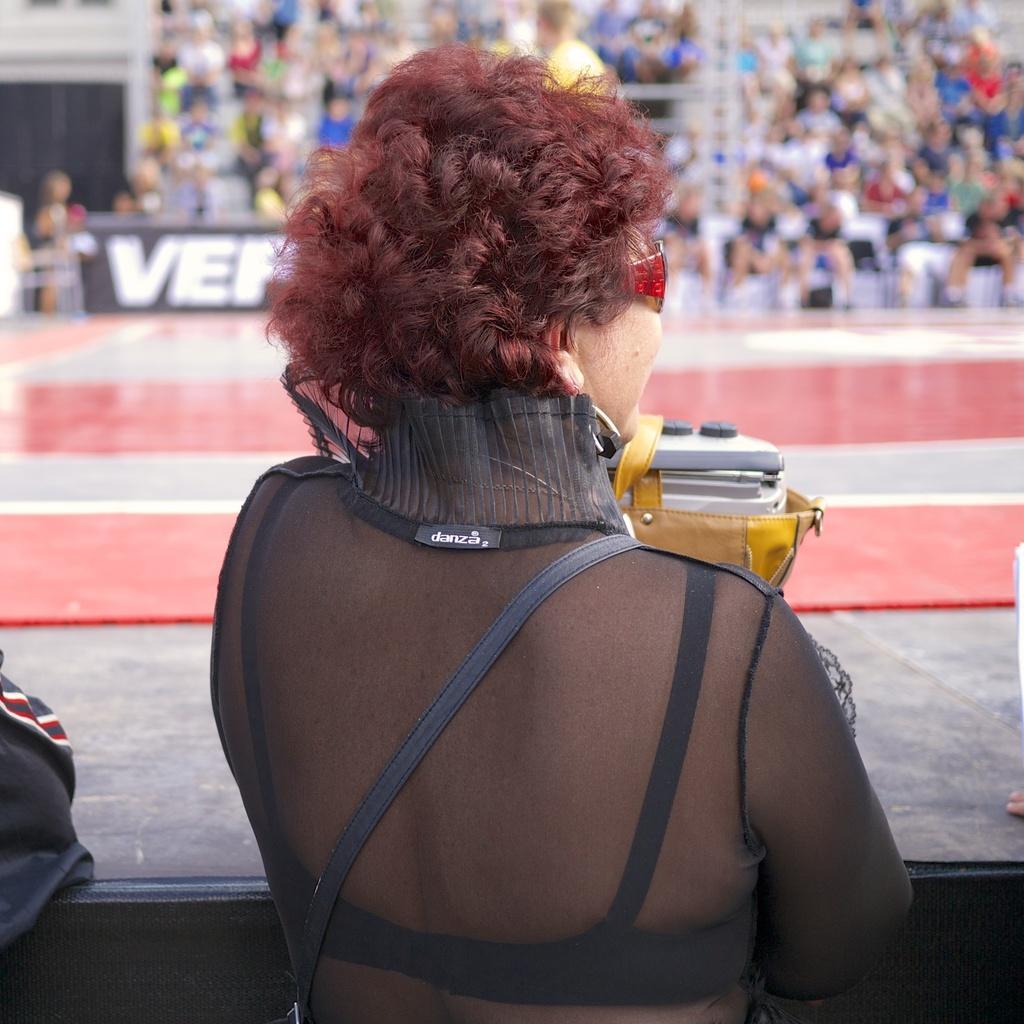Please provide a concise description of this image. In this image we can see a woman wearing goggles, in the background, we can see a few people sitting on the chairs and also we can see a board with some text. 